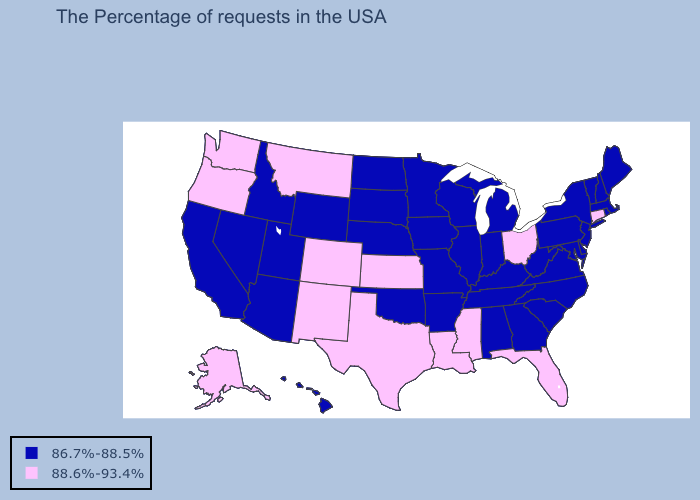Among the states that border Kansas , which have the highest value?
Concise answer only. Colorado. What is the lowest value in the West?
Concise answer only. 86.7%-88.5%. Among the states that border Utah , does New Mexico have the highest value?
Quick response, please. Yes. Name the states that have a value in the range 88.6%-93.4%?
Be succinct. Connecticut, Ohio, Florida, Mississippi, Louisiana, Kansas, Texas, Colorado, New Mexico, Montana, Washington, Oregon, Alaska. Name the states that have a value in the range 86.7%-88.5%?
Be succinct. Maine, Massachusetts, Rhode Island, New Hampshire, Vermont, New York, New Jersey, Delaware, Maryland, Pennsylvania, Virginia, North Carolina, South Carolina, West Virginia, Georgia, Michigan, Kentucky, Indiana, Alabama, Tennessee, Wisconsin, Illinois, Missouri, Arkansas, Minnesota, Iowa, Nebraska, Oklahoma, South Dakota, North Dakota, Wyoming, Utah, Arizona, Idaho, Nevada, California, Hawaii. What is the lowest value in the West?
Be succinct. 86.7%-88.5%. What is the value of North Dakota?
Answer briefly. 86.7%-88.5%. What is the lowest value in states that border Indiana?
Write a very short answer. 86.7%-88.5%. Does Connecticut have the highest value in the Northeast?
Answer briefly. Yes. How many symbols are there in the legend?
Give a very brief answer. 2. Name the states that have a value in the range 88.6%-93.4%?
Give a very brief answer. Connecticut, Ohio, Florida, Mississippi, Louisiana, Kansas, Texas, Colorado, New Mexico, Montana, Washington, Oregon, Alaska. Does the first symbol in the legend represent the smallest category?
Be succinct. Yes. Does Delaware have the lowest value in the South?
Give a very brief answer. Yes. What is the value of California?
Write a very short answer. 86.7%-88.5%. 